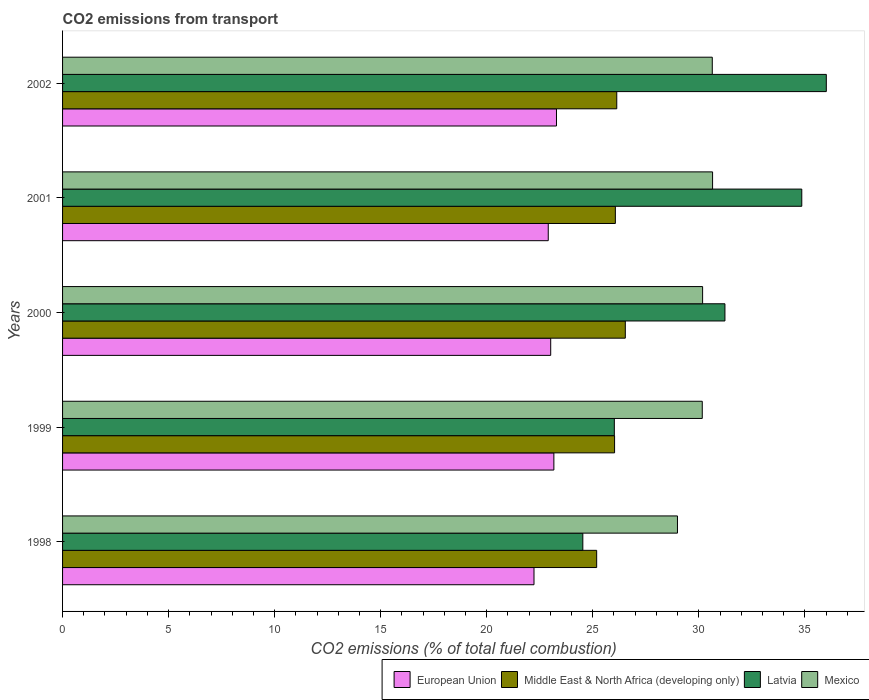How many groups of bars are there?
Your answer should be very brief. 5. What is the label of the 1st group of bars from the top?
Your answer should be very brief. 2002. In how many cases, is the number of bars for a given year not equal to the number of legend labels?
Provide a short and direct response. 0. What is the total CO2 emitted in European Union in 2000?
Your response must be concise. 23.02. Across all years, what is the maximum total CO2 emitted in Mexico?
Provide a short and direct response. 30.65. Across all years, what is the minimum total CO2 emitted in Middle East & North Africa (developing only)?
Your answer should be very brief. 25.18. In which year was the total CO2 emitted in Latvia maximum?
Keep it short and to the point. 2002. What is the total total CO2 emitted in Latvia in the graph?
Your response must be concise. 152.64. What is the difference between the total CO2 emitted in European Union in 1998 and that in 2000?
Offer a very short reply. -0.79. What is the difference between the total CO2 emitted in Mexico in 2000 and the total CO2 emitted in Latvia in 1998?
Your response must be concise. 5.65. What is the average total CO2 emitted in Latvia per year?
Provide a short and direct response. 30.53. In the year 1999, what is the difference between the total CO2 emitted in Middle East & North Africa (developing only) and total CO2 emitted in European Union?
Offer a terse response. 2.86. In how many years, is the total CO2 emitted in Latvia greater than 22 ?
Provide a short and direct response. 5. What is the ratio of the total CO2 emitted in Middle East & North Africa (developing only) in 1999 to that in 2000?
Your answer should be compact. 0.98. Is the difference between the total CO2 emitted in Middle East & North Africa (developing only) in 1998 and 1999 greater than the difference between the total CO2 emitted in European Union in 1998 and 1999?
Provide a short and direct response. Yes. What is the difference between the highest and the second highest total CO2 emitted in Latvia?
Your response must be concise. 1.16. What is the difference between the highest and the lowest total CO2 emitted in European Union?
Make the answer very short. 1.06. Is it the case that in every year, the sum of the total CO2 emitted in Middle East & North Africa (developing only) and total CO2 emitted in European Union is greater than the sum of total CO2 emitted in Latvia and total CO2 emitted in Mexico?
Your answer should be very brief. Yes. What does the 3rd bar from the top in 1998 represents?
Provide a succinct answer. Middle East & North Africa (developing only). What does the 4th bar from the bottom in 2002 represents?
Your answer should be compact. Mexico. What is the difference between two consecutive major ticks on the X-axis?
Offer a terse response. 5. Does the graph contain any zero values?
Provide a short and direct response. No. How many legend labels are there?
Your answer should be very brief. 4. What is the title of the graph?
Make the answer very short. CO2 emissions from transport. What is the label or title of the X-axis?
Ensure brevity in your answer.  CO2 emissions (% of total fuel combustion). What is the CO2 emissions (% of total fuel combustion) in European Union in 1998?
Give a very brief answer. 22.23. What is the CO2 emissions (% of total fuel combustion) of Middle East & North Africa (developing only) in 1998?
Give a very brief answer. 25.18. What is the CO2 emissions (% of total fuel combustion) of Latvia in 1998?
Provide a short and direct response. 24.53. What is the CO2 emissions (% of total fuel combustion) in Mexico in 1998?
Make the answer very short. 28.99. What is the CO2 emissions (% of total fuel combustion) in European Union in 1999?
Provide a succinct answer. 23.17. What is the CO2 emissions (% of total fuel combustion) of Middle East & North Africa (developing only) in 1999?
Make the answer very short. 26.03. What is the CO2 emissions (% of total fuel combustion) of Latvia in 1999?
Ensure brevity in your answer.  26.02. What is the CO2 emissions (% of total fuel combustion) of Mexico in 1999?
Your response must be concise. 30.16. What is the CO2 emissions (% of total fuel combustion) in European Union in 2000?
Provide a short and direct response. 23.02. What is the CO2 emissions (% of total fuel combustion) in Middle East & North Africa (developing only) in 2000?
Keep it short and to the point. 26.53. What is the CO2 emissions (% of total fuel combustion) of Latvia in 2000?
Provide a short and direct response. 31.23. What is the CO2 emissions (% of total fuel combustion) of Mexico in 2000?
Provide a short and direct response. 30.18. What is the CO2 emissions (% of total fuel combustion) of European Union in 2001?
Give a very brief answer. 22.9. What is the CO2 emissions (% of total fuel combustion) of Middle East & North Africa (developing only) in 2001?
Keep it short and to the point. 26.06. What is the CO2 emissions (% of total fuel combustion) in Latvia in 2001?
Provide a short and direct response. 34.85. What is the CO2 emissions (% of total fuel combustion) of Mexico in 2001?
Make the answer very short. 30.65. What is the CO2 emissions (% of total fuel combustion) in European Union in 2002?
Make the answer very short. 23.29. What is the CO2 emissions (% of total fuel combustion) in Middle East & North Africa (developing only) in 2002?
Ensure brevity in your answer.  26.13. What is the CO2 emissions (% of total fuel combustion) of Latvia in 2002?
Provide a succinct answer. 36.01. What is the CO2 emissions (% of total fuel combustion) of Mexico in 2002?
Offer a terse response. 30.63. Across all years, what is the maximum CO2 emissions (% of total fuel combustion) in European Union?
Your answer should be very brief. 23.29. Across all years, what is the maximum CO2 emissions (% of total fuel combustion) in Middle East & North Africa (developing only)?
Your answer should be very brief. 26.53. Across all years, what is the maximum CO2 emissions (% of total fuel combustion) in Latvia?
Provide a short and direct response. 36.01. Across all years, what is the maximum CO2 emissions (% of total fuel combustion) of Mexico?
Ensure brevity in your answer.  30.65. Across all years, what is the minimum CO2 emissions (% of total fuel combustion) in European Union?
Offer a very short reply. 22.23. Across all years, what is the minimum CO2 emissions (% of total fuel combustion) in Middle East & North Africa (developing only)?
Your response must be concise. 25.18. Across all years, what is the minimum CO2 emissions (% of total fuel combustion) in Latvia?
Ensure brevity in your answer.  24.53. Across all years, what is the minimum CO2 emissions (% of total fuel combustion) in Mexico?
Give a very brief answer. 28.99. What is the total CO2 emissions (% of total fuel combustion) in European Union in the graph?
Keep it short and to the point. 114.6. What is the total CO2 emissions (% of total fuel combustion) of Middle East & North Africa (developing only) in the graph?
Give a very brief answer. 129.94. What is the total CO2 emissions (% of total fuel combustion) of Latvia in the graph?
Your response must be concise. 152.64. What is the total CO2 emissions (% of total fuel combustion) in Mexico in the graph?
Your answer should be very brief. 150.62. What is the difference between the CO2 emissions (% of total fuel combustion) in European Union in 1998 and that in 1999?
Offer a terse response. -0.94. What is the difference between the CO2 emissions (% of total fuel combustion) in Middle East & North Africa (developing only) in 1998 and that in 1999?
Keep it short and to the point. -0.84. What is the difference between the CO2 emissions (% of total fuel combustion) of Latvia in 1998 and that in 1999?
Your answer should be very brief. -1.49. What is the difference between the CO2 emissions (% of total fuel combustion) in Mexico in 1998 and that in 1999?
Provide a succinct answer. -1.17. What is the difference between the CO2 emissions (% of total fuel combustion) of European Union in 1998 and that in 2000?
Provide a short and direct response. -0.79. What is the difference between the CO2 emissions (% of total fuel combustion) of Middle East & North Africa (developing only) in 1998 and that in 2000?
Ensure brevity in your answer.  -1.35. What is the difference between the CO2 emissions (% of total fuel combustion) of Latvia in 1998 and that in 2000?
Your response must be concise. -6.7. What is the difference between the CO2 emissions (% of total fuel combustion) of Mexico in 1998 and that in 2000?
Provide a succinct answer. -1.19. What is the difference between the CO2 emissions (% of total fuel combustion) in European Union in 1998 and that in 2001?
Give a very brief answer. -0.67. What is the difference between the CO2 emissions (% of total fuel combustion) of Middle East & North Africa (developing only) in 1998 and that in 2001?
Ensure brevity in your answer.  -0.88. What is the difference between the CO2 emissions (% of total fuel combustion) of Latvia in 1998 and that in 2001?
Provide a short and direct response. -10.32. What is the difference between the CO2 emissions (% of total fuel combustion) of Mexico in 1998 and that in 2001?
Your answer should be very brief. -1.66. What is the difference between the CO2 emissions (% of total fuel combustion) of European Union in 1998 and that in 2002?
Offer a very short reply. -1.06. What is the difference between the CO2 emissions (% of total fuel combustion) in Middle East & North Africa (developing only) in 1998 and that in 2002?
Offer a very short reply. -0.95. What is the difference between the CO2 emissions (% of total fuel combustion) in Latvia in 1998 and that in 2002?
Offer a terse response. -11.48. What is the difference between the CO2 emissions (% of total fuel combustion) of Mexico in 1998 and that in 2002?
Offer a very short reply. -1.64. What is the difference between the CO2 emissions (% of total fuel combustion) of European Union in 1999 and that in 2000?
Offer a very short reply. 0.15. What is the difference between the CO2 emissions (% of total fuel combustion) in Middle East & North Africa (developing only) in 1999 and that in 2000?
Make the answer very short. -0.51. What is the difference between the CO2 emissions (% of total fuel combustion) of Latvia in 1999 and that in 2000?
Keep it short and to the point. -5.22. What is the difference between the CO2 emissions (% of total fuel combustion) in Mexico in 1999 and that in 2000?
Your response must be concise. -0.02. What is the difference between the CO2 emissions (% of total fuel combustion) in European Union in 1999 and that in 2001?
Provide a short and direct response. 0.27. What is the difference between the CO2 emissions (% of total fuel combustion) of Middle East & North Africa (developing only) in 1999 and that in 2001?
Keep it short and to the point. -0.04. What is the difference between the CO2 emissions (% of total fuel combustion) in Latvia in 1999 and that in 2001?
Provide a short and direct response. -8.84. What is the difference between the CO2 emissions (% of total fuel combustion) of Mexico in 1999 and that in 2001?
Give a very brief answer. -0.49. What is the difference between the CO2 emissions (% of total fuel combustion) in European Union in 1999 and that in 2002?
Make the answer very short. -0.12. What is the difference between the CO2 emissions (% of total fuel combustion) in Middle East & North Africa (developing only) in 1999 and that in 2002?
Keep it short and to the point. -0.1. What is the difference between the CO2 emissions (% of total fuel combustion) of Latvia in 1999 and that in 2002?
Make the answer very short. -9.99. What is the difference between the CO2 emissions (% of total fuel combustion) of Mexico in 1999 and that in 2002?
Your answer should be very brief. -0.47. What is the difference between the CO2 emissions (% of total fuel combustion) in European Union in 2000 and that in 2001?
Give a very brief answer. 0.12. What is the difference between the CO2 emissions (% of total fuel combustion) in Middle East & North Africa (developing only) in 2000 and that in 2001?
Offer a terse response. 0.47. What is the difference between the CO2 emissions (% of total fuel combustion) of Latvia in 2000 and that in 2001?
Your response must be concise. -3.62. What is the difference between the CO2 emissions (% of total fuel combustion) of Mexico in 2000 and that in 2001?
Ensure brevity in your answer.  -0.47. What is the difference between the CO2 emissions (% of total fuel combustion) in European Union in 2000 and that in 2002?
Provide a short and direct response. -0.27. What is the difference between the CO2 emissions (% of total fuel combustion) in Middle East & North Africa (developing only) in 2000 and that in 2002?
Keep it short and to the point. 0.4. What is the difference between the CO2 emissions (% of total fuel combustion) in Latvia in 2000 and that in 2002?
Provide a succinct answer. -4.78. What is the difference between the CO2 emissions (% of total fuel combustion) of Mexico in 2000 and that in 2002?
Provide a short and direct response. -0.46. What is the difference between the CO2 emissions (% of total fuel combustion) in European Union in 2001 and that in 2002?
Your answer should be very brief. -0.39. What is the difference between the CO2 emissions (% of total fuel combustion) in Middle East & North Africa (developing only) in 2001 and that in 2002?
Offer a terse response. -0.07. What is the difference between the CO2 emissions (% of total fuel combustion) of Latvia in 2001 and that in 2002?
Your response must be concise. -1.16. What is the difference between the CO2 emissions (% of total fuel combustion) of Mexico in 2001 and that in 2002?
Your answer should be very brief. 0.01. What is the difference between the CO2 emissions (% of total fuel combustion) in European Union in 1998 and the CO2 emissions (% of total fuel combustion) in Middle East & North Africa (developing only) in 1999?
Provide a short and direct response. -3.8. What is the difference between the CO2 emissions (% of total fuel combustion) in European Union in 1998 and the CO2 emissions (% of total fuel combustion) in Latvia in 1999?
Your response must be concise. -3.79. What is the difference between the CO2 emissions (% of total fuel combustion) in European Union in 1998 and the CO2 emissions (% of total fuel combustion) in Mexico in 1999?
Your answer should be compact. -7.93. What is the difference between the CO2 emissions (% of total fuel combustion) of Middle East & North Africa (developing only) in 1998 and the CO2 emissions (% of total fuel combustion) of Latvia in 1999?
Ensure brevity in your answer.  -0.83. What is the difference between the CO2 emissions (% of total fuel combustion) of Middle East & North Africa (developing only) in 1998 and the CO2 emissions (% of total fuel combustion) of Mexico in 1999?
Offer a very short reply. -4.98. What is the difference between the CO2 emissions (% of total fuel combustion) in Latvia in 1998 and the CO2 emissions (% of total fuel combustion) in Mexico in 1999?
Offer a very short reply. -5.63. What is the difference between the CO2 emissions (% of total fuel combustion) of European Union in 1998 and the CO2 emissions (% of total fuel combustion) of Middle East & North Africa (developing only) in 2000?
Provide a succinct answer. -4.31. What is the difference between the CO2 emissions (% of total fuel combustion) in European Union in 1998 and the CO2 emissions (% of total fuel combustion) in Latvia in 2000?
Keep it short and to the point. -9. What is the difference between the CO2 emissions (% of total fuel combustion) of European Union in 1998 and the CO2 emissions (% of total fuel combustion) of Mexico in 2000?
Your answer should be very brief. -7.95. What is the difference between the CO2 emissions (% of total fuel combustion) of Middle East & North Africa (developing only) in 1998 and the CO2 emissions (% of total fuel combustion) of Latvia in 2000?
Provide a succinct answer. -6.05. What is the difference between the CO2 emissions (% of total fuel combustion) of Middle East & North Africa (developing only) in 1998 and the CO2 emissions (% of total fuel combustion) of Mexico in 2000?
Give a very brief answer. -5. What is the difference between the CO2 emissions (% of total fuel combustion) of Latvia in 1998 and the CO2 emissions (% of total fuel combustion) of Mexico in 2000?
Ensure brevity in your answer.  -5.65. What is the difference between the CO2 emissions (% of total fuel combustion) of European Union in 1998 and the CO2 emissions (% of total fuel combustion) of Middle East & North Africa (developing only) in 2001?
Provide a succinct answer. -3.84. What is the difference between the CO2 emissions (% of total fuel combustion) of European Union in 1998 and the CO2 emissions (% of total fuel combustion) of Latvia in 2001?
Offer a very short reply. -12.63. What is the difference between the CO2 emissions (% of total fuel combustion) in European Union in 1998 and the CO2 emissions (% of total fuel combustion) in Mexico in 2001?
Keep it short and to the point. -8.42. What is the difference between the CO2 emissions (% of total fuel combustion) of Middle East & North Africa (developing only) in 1998 and the CO2 emissions (% of total fuel combustion) of Latvia in 2001?
Your answer should be compact. -9.67. What is the difference between the CO2 emissions (% of total fuel combustion) of Middle East & North Africa (developing only) in 1998 and the CO2 emissions (% of total fuel combustion) of Mexico in 2001?
Make the answer very short. -5.47. What is the difference between the CO2 emissions (% of total fuel combustion) in Latvia in 1998 and the CO2 emissions (% of total fuel combustion) in Mexico in 2001?
Offer a very short reply. -6.12. What is the difference between the CO2 emissions (% of total fuel combustion) of European Union in 1998 and the CO2 emissions (% of total fuel combustion) of Middle East & North Africa (developing only) in 2002?
Your answer should be compact. -3.9. What is the difference between the CO2 emissions (% of total fuel combustion) in European Union in 1998 and the CO2 emissions (% of total fuel combustion) in Latvia in 2002?
Ensure brevity in your answer.  -13.78. What is the difference between the CO2 emissions (% of total fuel combustion) of European Union in 1998 and the CO2 emissions (% of total fuel combustion) of Mexico in 2002?
Your response must be concise. -8.41. What is the difference between the CO2 emissions (% of total fuel combustion) of Middle East & North Africa (developing only) in 1998 and the CO2 emissions (% of total fuel combustion) of Latvia in 2002?
Make the answer very short. -10.83. What is the difference between the CO2 emissions (% of total fuel combustion) in Middle East & North Africa (developing only) in 1998 and the CO2 emissions (% of total fuel combustion) in Mexico in 2002?
Provide a short and direct response. -5.45. What is the difference between the CO2 emissions (% of total fuel combustion) of Latvia in 1998 and the CO2 emissions (% of total fuel combustion) of Mexico in 2002?
Make the answer very short. -6.1. What is the difference between the CO2 emissions (% of total fuel combustion) of European Union in 1999 and the CO2 emissions (% of total fuel combustion) of Middle East & North Africa (developing only) in 2000?
Ensure brevity in your answer.  -3.37. What is the difference between the CO2 emissions (% of total fuel combustion) of European Union in 1999 and the CO2 emissions (% of total fuel combustion) of Latvia in 2000?
Provide a succinct answer. -8.07. What is the difference between the CO2 emissions (% of total fuel combustion) of European Union in 1999 and the CO2 emissions (% of total fuel combustion) of Mexico in 2000?
Offer a terse response. -7.01. What is the difference between the CO2 emissions (% of total fuel combustion) of Middle East & North Africa (developing only) in 1999 and the CO2 emissions (% of total fuel combustion) of Latvia in 2000?
Provide a short and direct response. -5.2. What is the difference between the CO2 emissions (% of total fuel combustion) in Middle East & North Africa (developing only) in 1999 and the CO2 emissions (% of total fuel combustion) in Mexico in 2000?
Your answer should be very brief. -4.15. What is the difference between the CO2 emissions (% of total fuel combustion) in Latvia in 1999 and the CO2 emissions (% of total fuel combustion) in Mexico in 2000?
Your answer should be compact. -4.16. What is the difference between the CO2 emissions (% of total fuel combustion) of European Union in 1999 and the CO2 emissions (% of total fuel combustion) of Middle East & North Africa (developing only) in 2001?
Your answer should be very brief. -2.9. What is the difference between the CO2 emissions (% of total fuel combustion) of European Union in 1999 and the CO2 emissions (% of total fuel combustion) of Latvia in 2001?
Make the answer very short. -11.69. What is the difference between the CO2 emissions (% of total fuel combustion) of European Union in 1999 and the CO2 emissions (% of total fuel combustion) of Mexico in 2001?
Your answer should be compact. -7.48. What is the difference between the CO2 emissions (% of total fuel combustion) in Middle East & North Africa (developing only) in 1999 and the CO2 emissions (% of total fuel combustion) in Latvia in 2001?
Provide a short and direct response. -8.83. What is the difference between the CO2 emissions (% of total fuel combustion) in Middle East & North Africa (developing only) in 1999 and the CO2 emissions (% of total fuel combustion) in Mexico in 2001?
Ensure brevity in your answer.  -4.62. What is the difference between the CO2 emissions (% of total fuel combustion) of Latvia in 1999 and the CO2 emissions (% of total fuel combustion) of Mexico in 2001?
Your answer should be very brief. -4.63. What is the difference between the CO2 emissions (% of total fuel combustion) in European Union in 1999 and the CO2 emissions (% of total fuel combustion) in Middle East & North Africa (developing only) in 2002?
Make the answer very short. -2.97. What is the difference between the CO2 emissions (% of total fuel combustion) in European Union in 1999 and the CO2 emissions (% of total fuel combustion) in Latvia in 2002?
Your answer should be very brief. -12.85. What is the difference between the CO2 emissions (% of total fuel combustion) of European Union in 1999 and the CO2 emissions (% of total fuel combustion) of Mexico in 2002?
Keep it short and to the point. -7.47. What is the difference between the CO2 emissions (% of total fuel combustion) in Middle East & North Africa (developing only) in 1999 and the CO2 emissions (% of total fuel combustion) in Latvia in 2002?
Give a very brief answer. -9.98. What is the difference between the CO2 emissions (% of total fuel combustion) of Middle East & North Africa (developing only) in 1999 and the CO2 emissions (% of total fuel combustion) of Mexico in 2002?
Your answer should be very brief. -4.61. What is the difference between the CO2 emissions (% of total fuel combustion) of Latvia in 1999 and the CO2 emissions (% of total fuel combustion) of Mexico in 2002?
Offer a terse response. -4.62. What is the difference between the CO2 emissions (% of total fuel combustion) in European Union in 2000 and the CO2 emissions (% of total fuel combustion) in Middle East & North Africa (developing only) in 2001?
Ensure brevity in your answer.  -3.05. What is the difference between the CO2 emissions (% of total fuel combustion) in European Union in 2000 and the CO2 emissions (% of total fuel combustion) in Latvia in 2001?
Offer a very short reply. -11.84. What is the difference between the CO2 emissions (% of total fuel combustion) of European Union in 2000 and the CO2 emissions (% of total fuel combustion) of Mexico in 2001?
Provide a short and direct response. -7.63. What is the difference between the CO2 emissions (% of total fuel combustion) in Middle East & North Africa (developing only) in 2000 and the CO2 emissions (% of total fuel combustion) in Latvia in 2001?
Your response must be concise. -8.32. What is the difference between the CO2 emissions (% of total fuel combustion) in Middle East & North Africa (developing only) in 2000 and the CO2 emissions (% of total fuel combustion) in Mexico in 2001?
Make the answer very short. -4.11. What is the difference between the CO2 emissions (% of total fuel combustion) in Latvia in 2000 and the CO2 emissions (% of total fuel combustion) in Mexico in 2001?
Ensure brevity in your answer.  0.58. What is the difference between the CO2 emissions (% of total fuel combustion) in European Union in 2000 and the CO2 emissions (% of total fuel combustion) in Middle East & North Africa (developing only) in 2002?
Make the answer very short. -3.12. What is the difference between the CO2 emissions (% of total fuel combustion) in European Union in 2000 and the CO2 emissions (% of total fuel combustion) in Latvia in 2002?
Offer a very short reply. -12.99. What is the difference between the CO2 emissions (% of total fuel combustion) of European Union in 2000 and the CO2 emissions (% of total fuel combustion) of Mexico in 2002?
Give a very brief answer. -7.62. What is the difference between the CO2 emissions (% of total fuel combustion) of Middle East & North Africa (developing only) in 2000 and the CO2 emissions (% of total fuel combustion) of Latvia in 2002?
Your response must be concise. -9.48. What is the difference between the CO2 emissions (% of total fuel combustion) in Middle East & North Africa (developing only) in 2000 and the CO2 emissions (% of total fuel combustion) in Mexico in 2002?
Your answer should be compact. -4.1. What is the difference between the CO2 emissions (% of total fuel combustion) in Latvia in 2000 and the CO2 emissions (% of total fuel combustion) in Mexico in 2002?
Keep it short and to the point. 0.6. What is the difference between the CO2 emissions (% of total fuel combustion) in European Union in 2001 and the CO2 emissions (% of total fuel combustion) in Middle East & North Africa (developing only) in 2002?
Your response must be concise. -3.23. What is the difference between the CO2 emissions (% of total fuel combustion) in European Union in 2001 and the CO2 emissions (% of total fuel combustion) in Latvia in 2002?
Offer a terse response. -13.11. What is the difference between the CO2 emissions (% of total fuel combustion) in European Union in 2001 and the CO2 emissions (% of total fuel combustion) in Mexico in 2002?
Make the answer very short. -7.73. What is the difference between the CO2 emissions (% of total fuel combustion) in Middle East & North Africa (developing only) in 2001 and the CO2 emissions (% of total fuel combustion) in Latvia in 2002?
Give a very brief answer. -9.95. What is the difference between the CO2 emissions (% of total fuel combustion) in Middle East & North Africa (developing only) in 2001 and the CO2 emissions (% of total fuel combustion) in Mexico in 2002?
Give a very brief answer. -4.57. What is the difference between the CO2 emissions (% of total fuel combustion) in Latvia in 2001 and the CO2 emissions (% of total fuel combustion) in Mexico in 2002?
Your answer should be very brief. 4.22. What is the average CO2 emissions (% of total fuel combustion) in European Union per year?
Provide a short and direct response. 22.92. What is the average CO2 emissions (% of total fuel combustion) of Middle East & North Africa (developing only) per year?
Keep it short and to the point. 25.99. What is the average CO2 emissions (% of total fuel combustion) of Latvia per year?
Provide a succinct answer. 30.53. What is the average CO2 emissions (% of total fuel combustion) in Mexico per year?
Offer a terse response. 30.12. In the year 1998, what is the difference between the CO2 emissions (% of total fuel combustion) of European Union and CO2 emissions (% of total fuel combustion) of Middle East & North Africa (developing only)?
Keep it short and to the point. -2.96. In the year 1998, what is the difference between the CO2 emissions (% of total fuel combustion) in European Union and CO2 emissions (% of total fuel combustion) in Latvia?
Make the answer very short. -2.3. In the year 1998, what is the difference between the CO2 emissions (% of total fuel combustion) in European Union and CO2 emissions (% of total fuel combustion) in Mexico?
Ensure brevity in your answer.  -6.76. In the year 1998, what is the difference between the CO2 emissions (% of total fuel combustion) in Middle East & North Africa (developing only) and CO2 emissions (% of total fuel combustion) in Latvia?
Keep it short and to the point. 0.65. In the year 1998, what is the difference between the CO2 emissions (% of total fuel combustion) in Middle East & North Africa (developing only) and CO2 emissions (% of total fuel combustion) in Mexico?
Keep it short and to the point. -3.81. In the year 1998, what is the difference between the CO2 emissions (% of total fuel combustion) of Latvia and CO2 emissions (% of total fuel combustion) of Mexico?
Keep it short and to the point. -4.46. In the year 1999, what is the difference between the CO2 emissions (% of total fuel combustion) of European Union and CO2 emissions (% of total fuel combustion) of Middle East & North Africa (developing only)?
Your answer should be compact. -2.86. In the year 1999, what is the difference between the CO2 emissions (% of total fuel combustion) of European Union and CO2 emissions (% of total fuel combustion) of Latvia?
Give a very brief answer. -2.85. In the year 1999, what is the difference between the CO2 emissions (% of total fuel combustion) of European Union and CO2 emissions (% of total fuel combustion) of Mexico?
Make the answer very short. -7. In the year 1999, what is the difference between the CO2 emissions (% of total fuel combustion) in Middle East & North Africa (developing only) and CO2 emissions (% of total fuel combustion) in Latvia?
Your answer should be compact. 0.01. In the year 1999, what is the difference between the CO2 emissions (% of total fuel combustion) of Middle East & North Africa (developing only) and CO2 emissions (% of total fuel combustion) of Mexico?
Give a very brief answer. -4.13. In the year 1999, what is the difference between the CO2 emissions (% of total fuel combustion) of Latvia and CO2 emissions (% of total fuel combustion) of Mexico?
Give a very brief answer. -4.15. In the year 2000, what is the difference between the CO2 emissions (% of total fuel combustion) of European Union and CO2 emissions (% of total fuel combustion) of Middle East & North Africa (developing only)?
Your answer should be compact. -3.52. In the year 2000, what is the difference between the CO2 emissions (% of total fuel combustion) of European Union and CO2 emissions (% of total fuel combustion) of Latvia?
Provide a short and direct response. -8.22. In the year 2000, what is the difference between the CO2 emissions (% of total fuel combustion) of European Union and CO2 emissions (% of total fuel combustion) of Mexico?
Your response must be concise. -7.16. In the year 2000, what is the difference between the CO2 emissions (% of total fuel combustion) of Middle East & North Africa (developing only) and CO2 emissions (% of total fuel combustion) of Latvia?
Offer a terse response. -4.7. In the year 2000, what is the difference between the CO2 emissions (% of total fuel combustion) in Middle East & North Africa (developing only) and CO2 emissions (% of total fuel combustion) in Mexico?
Keep it short and to the point. -3.64. In the year 2000, what is the difference between the CO2 emissions (% of total fuel combustion) of Latvia and CO2 emissions (% of total fuel combustion) of Mexico?
Provide a succinct answer. 1.05. In the year 2001, what is the difference between the CO2 emissions (% of total fuel combustion) in European Union and CO2 emissions (% of total fuel combustion) in Middle East & North Africa (developing only)?
Give a very brief answer. -3.16. In the year 2001, what is the difference between the CO2 emissions (% of total fuel combustion) of European Union and CO2 emissions (% of total fuel combustion) of Latvia?
Provide a short and direct response. -11.95. In the year 2001, what is the difference between the CO2 emissions (% of total fuel combustion) of European Union and CO2 emissions (% of total fuel combustion) of Mexico?
Keep it short and to the point. -7.75. In the year 2001, what is the difference between the CO2 emissions (% of total fuel combustion) in Middle East & North Africa (developing only) and CO2 emissions (% of total fuel combustion) in Latvia?
Make the answer very short. -8.79. In the year 2001, what is the difference between the CO2 emissions (% of total fuel combustion) in Middle East & North Africa (developing only) and CO2 emissions (% of total fuel combustion) in Mexico?
Offer a very short reply. -4.58. In the year 2001, what is the difference between the CO2 emissions (% of total fuel combustion) of Latvia and CO2 emissions (% of total fuel combustion) of Mexico?
Ensure brevity in your answer.  4.21. In the year 2002, what is the difference between the CO2 emissions (% of total fuel combustion) of European Union and CO2 emissions (% of total fuel combustion) of Middle East & North Africa (developing only)?
Keep it short and to the point. -2.84. In the year 2002, what is the difference between the CO2 emissions (% of total fuel combustion) in European Union and CO2 emissions (% of total fuel combustion) in Latvia?
Offer a terse response. -12.72. In the year 2002, what is the difference between the CO2 emissions (% of total fuel combustion) of European Union and CO2 emissions (% of total fuel combustion) of Mexico?
Give a very brief answer. -7.35. In the year 2002, what is the difference between the CO2 emissions (% of total fuel combustion) of Middle East & North Africa (developing only) and CO2 emissions (% of total fuel combustion) of Latvia?
Provide a succinct answer. -9.88. In the year 2002, what is the difference between the CO2 emissions (% of total fuel combustion) of Middle East & North Africa (developing only) and CO2 emissions (% of total fuel combustion) of Mexico?
Keep it short and to the point. -4.5. In the year 2002, what is the difference between the CO2 emissions (% of total fuel combustion) of Latvia and CO2 emissions (% of total fuel combustion) of Mexico?
Provide a succinct answer. 5.38. What is the ratio of the CO2 emissions (% of total fuel combustion) in European Union in 1998 to that in 1999?
Your answer should be compact. 0.96. What is the ratio of the CO2 emissions (% of total fuel combustion) in Middle East & North Africa (developing only) in 1998 to that in 1999?
Offer a very short reply. 0.97. What is the ratio of the CO2 emissions (% of total fuel combustion) in Latvia in 1998 to that in 1999?
Keep it short and to the point. 0.94. What is the ratio of the CO2 emissions (% of total fuel combustion) of Mexico in 1998 to that in 1999?
Your answer should be very brief. 0.96. What is the ratio of the CO2 emissions (% of total fuel combustion) in European Union in 1998 to that in 2000?
Provide a succinct answer. 0.97. What is the ratio of the CO2 emissions (% of total fuel combustion) in Middle East & North Africa (developing only) in 1998 to that in 2000?
Keep it short and to the point. 0.95. What is the ratio of the CO2 emissions (% of total fuel combustion) in Latvia in 1998 to that in 2000?
Provide a succinct answer. 0.79. What is the ratio of the CO2 emissions (% of total fuel combustion) in Mexico in 1998 to that in 2000?
Your answer should be very brief. 0.96. What is the ratio of the CO2 emissions (% of total fuel combustion) in European Union in 1998 to that in 2001?
Ensure brevity in your answer.  0.97. What is the ratio of the CO2 emissions (% of total fuel combustion) of Middle East & North Africa (developing only) in 1998 to that in 2001?
Offer a terse response. 0.97. What is the ratio of the CO2 emissions (% of total fuel combustion) of Latvia in 1998 to that in 2001?
Your response must be concise. 0.7. What is the ratio of the CO2 emissions (% of total fuel combustion) of Mexico in 1998 to that in 2001?
Make the answer very short. 0.95. What is the ratio of the CO2 emissions (% of total fuel combustion) of European Union in 1998 to that in 2002?
Keep it short and to the point. 0.95. What is the ratio of the CO2 emissions (% of total fuel combustion) in Middle East & North Africa (developing only) in 1998 to that in 2002?
Offer a terse response. 0.96. What is the ratio of the CO2 emissions (% of total fuel combustion) in Latvia in 1998 to that in 2002?
Provide a short and direct response. 0.68. What is the ratio of the CO2 emissions (% of total fuel combustion) in Mexico in 1998 to that in 2002?
Provide a short and direct response. 0.95. What is the ratio of the CO2 emissions (% of total fuel combustion) of Middle East & North Africa (developing only) in 1999 to that in 2000?
Give a very brief answer. 0.98. What is the ratio of the CO2 emissions (% of total fuel combustion) in Latvia in 1999 to that in 2000?
Give a very brief answer. 0.83. What is the ratio of the CO2 emissions (% of total fuel combustion) of European Union in 1999 to that in 2001?
Make the answer very short. 1.01. What is the ratio of the CO2 emissions (% of total fuel combustion) in Latvia in 1999 to that in 2001?
Your response must be concise. 0.75. What is the ratio of the CO2 emissions (% of total fuel combustion) in Mexico in 1999 to that in 2001?
Your answer should be very brief. 0.98. What is the ratio of the CO2 emissions (% of total fuel combustion) in European Union in 1999 to that in 2002?
Keep it short and to the point. 0.99. What is the ratio of the CO2 emissions (% of total fuel combustion) in Latvia in 1999 to that in 2002?
Provide a short and direct response. 0.72. What is the ratio of the CO2 emissions (% of total fuel combustion) of Mexico in 1999 to that in 2002?
Offer a terse response. 0.98. What is the ratio of the CO2 emissions (% of total fuel combustion) of European Union in 2000 to that in 2001?
Your response must be concise. 1.01. What is the ratio of the CO2 emissions (% of total fuel combustion) in Middle East & North Africa (developing only) in 2000 to that in 2001?
Provide a succinct answer. 1.02. What is the ratio of the CO2 emissions (% of total fuel combustion) in Latvia in 2000 to that in 2001?
Make the answer very short. 0.9. What is the ratio of the CO2 emissions (% of total fuel combustion) of Mexico in 2000 to that in 2001?
Offer a terse response. 0.98. What is the ratio of the CO2 emissions (% of total fuel combustion) in European Union in 2000 to that in 2002?
Offer a very short reply. 0.99. What is the ratio of the CO2 emissions (% of total fuel combustion) of Middle East & North Africa (developing only) in 2000 to that in 2002?
Give a very brief answer. 1.02. What is the ratio of the CO2 emissions (% of total fuel combustion) in Latvia in 2000 to that in 2002?
Your response must be concise. 0.87. What is the ratio of the CO2 emissions (% of total fuel combustion) of Mexico in 2000 to that in 2002?
Your response must be concise. 0.99. What is the ratio of the CO2 emissions (% of total fuel combustion) in European Union in 2001 to that in 2002?
Make the answer very short. 0.98. What is the ratio of the CO2 emissions (% of total fuel combustion) of Middle East & North Africa (developing only) in 2001 to that in 2002?
Your answer should be compact. 1. What is the ratio of the CO2 emissions (% of total fuel combustion) of Latvia in 2001 to that in 2002?
Provide a short and direct response. 0.97. What is the ratio of the CO2 emissions (% of total fuel combustion) of Mexico in 2001 to that in 2002?
Provide a short and direct response. 1. What is the difference between the highest and the second highest CO2 emissions (% of total fuel combustion) in European Union?
Make the answer very short. 0.12. What is the difference between the highest and the second highest CO2 emissions (% of total fuel combustion) in Middle East & North Africa (developing only)?
Your answer should be compact. 0.4. What is the difference between the highest and the second highest CO2 emissions (% of total fuel combustion) of Latvia?
Your answer should be very brief. 1.16. What is the difference between the highest and the second highest CO2 emissions (% of total fuel combustion) of Mexico?
Offer a terse response. 0.01. What is the difference between the highest and the lowest CO2 emissions (% of total fuel combustion) in European Union?
Keep it short and to the point. 1.06. What is the difference between the highest and the lowest CO2 emissions (% of total fuel combustion) of Middle East & North Africa (developing only)?
Make the answer very short. 1.35. What is the difference between the highest and the lowest CO2 emissions (% of total fuel combustion) in Latvia?
Give a very brief answer. 11.48. What is the difference between the highest and the lowest CO2 emissions (% of total fuel combustion) in Mexico?
Offer a very short reply. 1.66. 